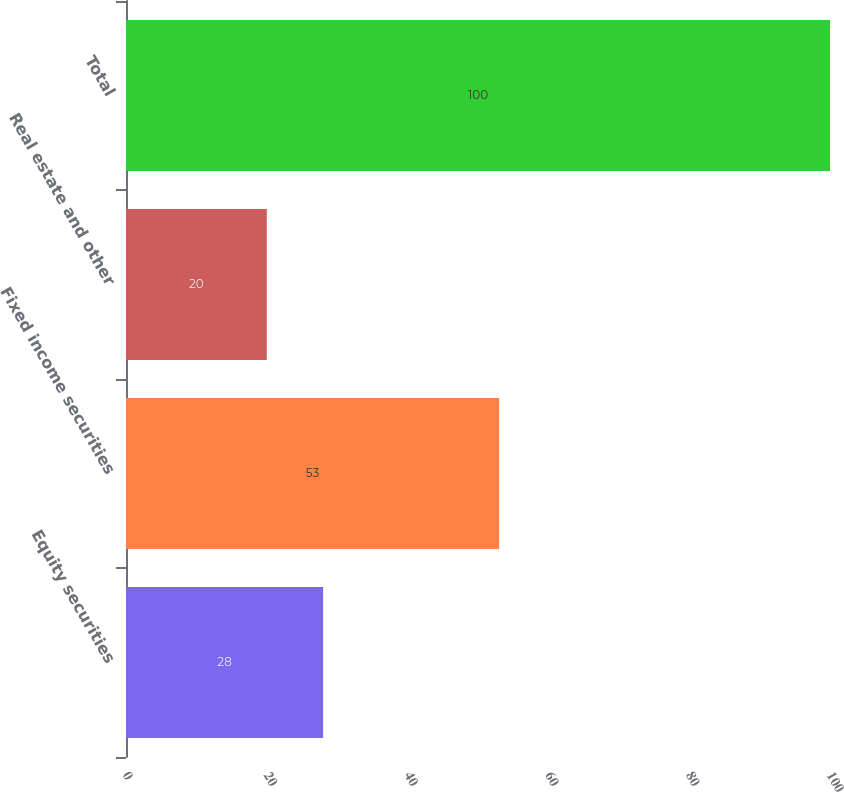Convert chart to OTSL. <chart><loc_0><loc_0><loc_500><loc_500><bar_chart><fcel>Equity securities<fcel>Fixed income securities<fcel>Real estate and other<fcel>Total<nl><fcel>28<fcel>53<fcel>20<fcel>100<nl></chart> 